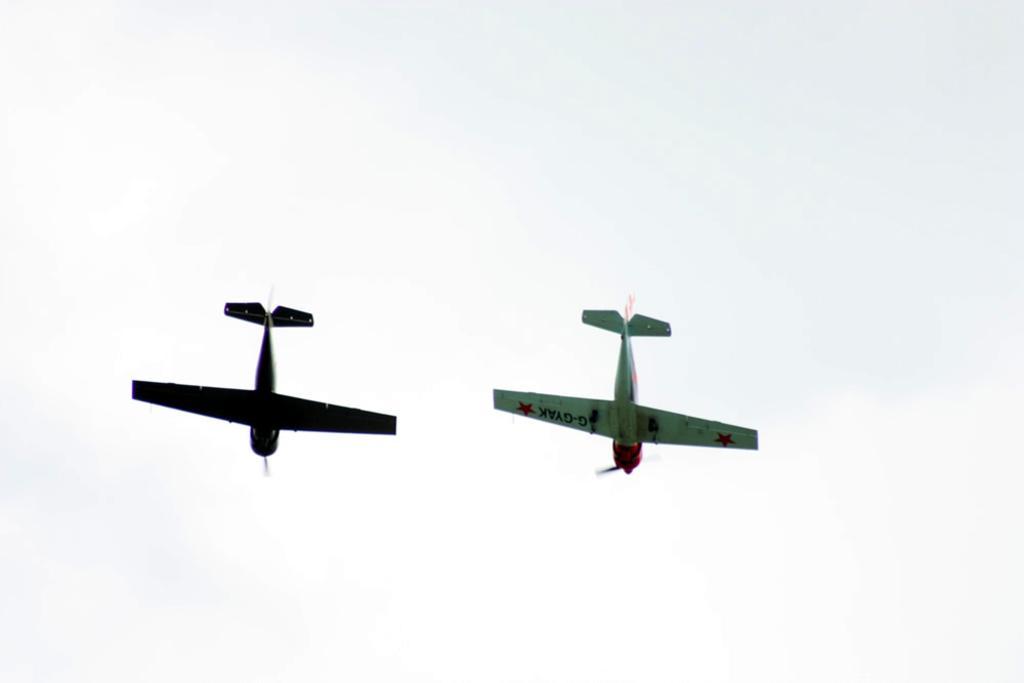Describe this image in one or two sentences. In this image we can see two aeroplanes in the air. In the background we can see sky. 